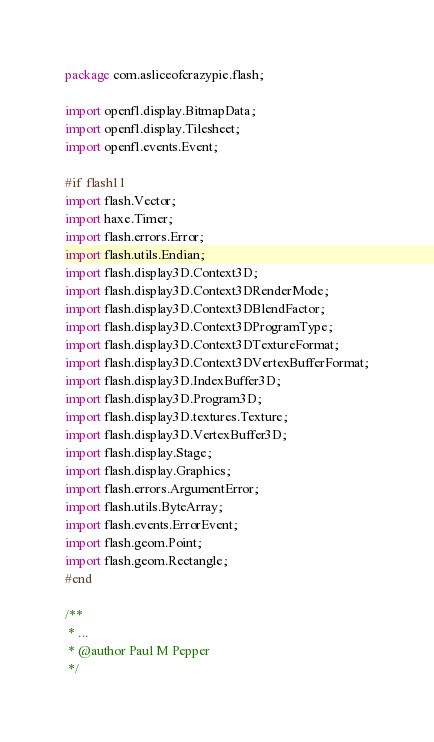Convert code to text. <code><loc_0><loc_0><loc_500><loc_500><_Haxe_>package com.asliceofcrazypie.flash;

import openfl.display.BitmapData;
import openfl.display.Tilesheet;
import openfl.events.Event;

#if flash11
import flash.Vector;
import haxe.Timer;
import flash.errors.Error;
import flash.utils.Endian;
import flash.display3D.Context3D;
import flash.display3D.Context3DRenderMode;
import flash.display3D.Context3DBlendFactor;
import flash.display3D.Context3DProgramType;
import flash.display3D.Context3DTextureFormat;
import flash.display3D.Context3DVertexBufferFormat;
import flash.display3D.IndexBuffer3D;
import flash.display3D.Program3D;
import flash.display3D.textures.Texture;
import flash.display3D.VertexBuffer3D;
import flash.display.Stage;
import flash.display.Graphics;
import flash.errors.ArgumentError;
import flash.utils.ByteArray;
import flash.events.ErrorEvent;
import flash.geom.Point;
import flash.geom.Rectangle;
#end

/**
 * ...
 * @author Paul M Pepper
 */</code> 